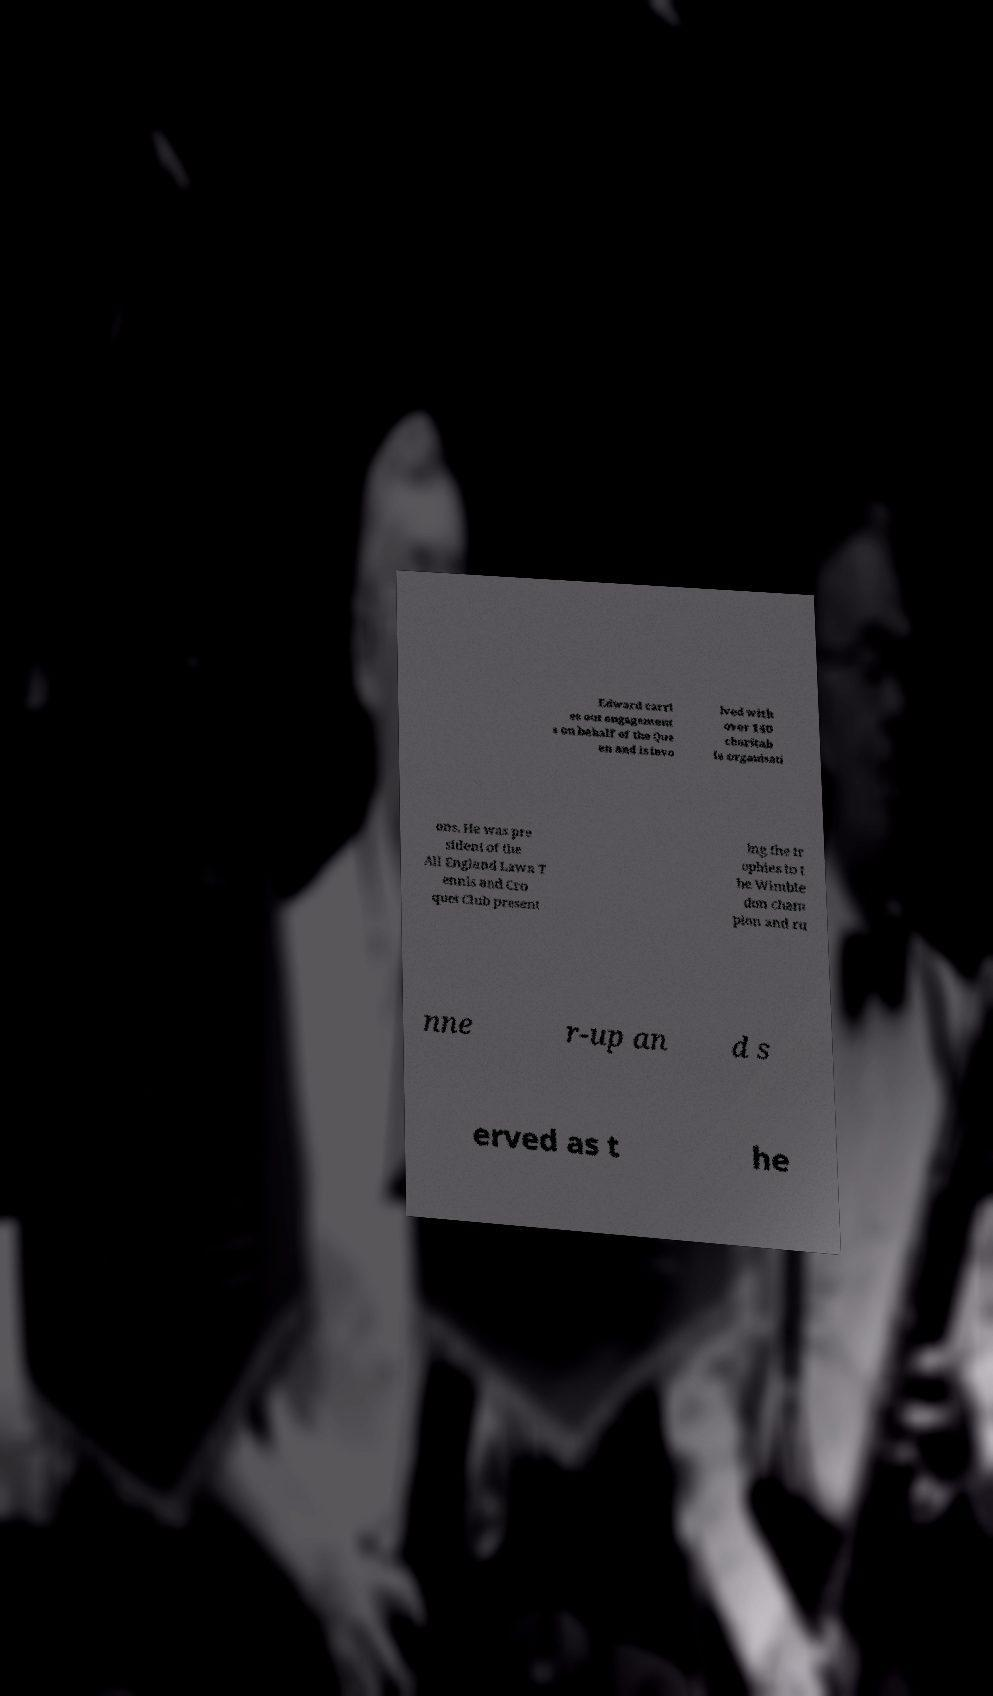Can you read and provide the text displayed in the image?This photo seems to have some interesting text. Can you extract and type it out for me? Edward carri es out engagement s on behalf of the Que en and is invo lved with over 140 charitab le organisati ons. He was pre sident of the All England Lawn T ennis and Cro quet Club present ing the tr ophies to t he Wimble don cham pion and ru nne r-up an d s erved as t he 